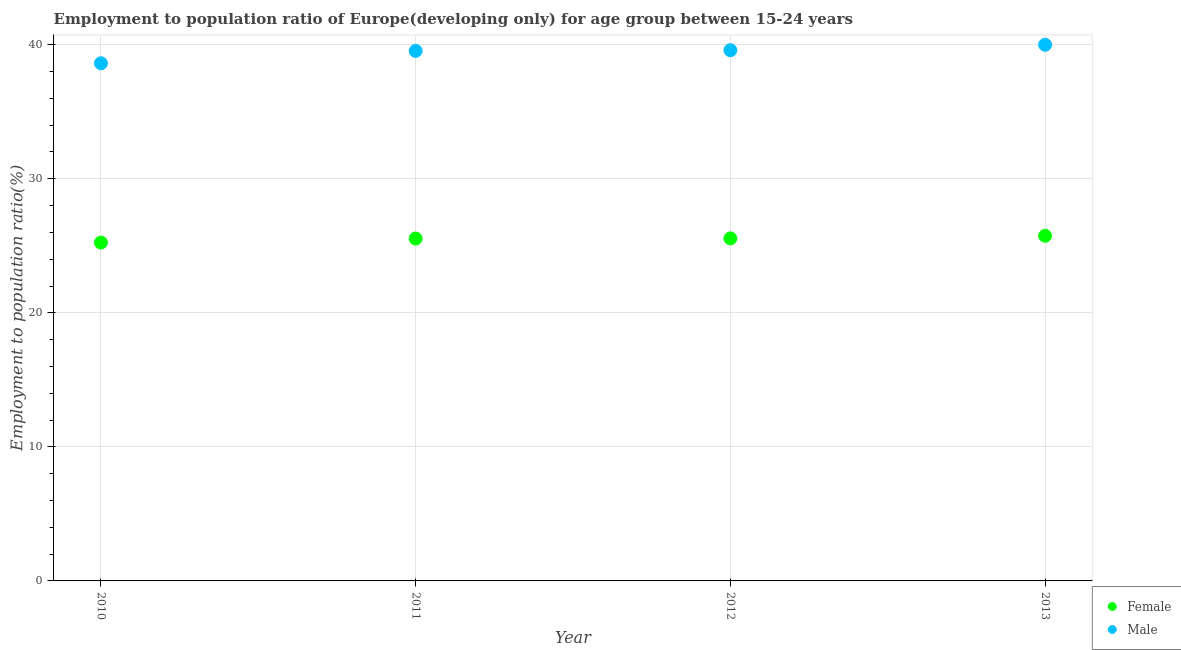How many different coloured dotlines are there?
Your answer should be compact. 2. What is the employment to population ratio(female) in 2012?
Provide a short and direct response. 25.56. Across all years, what is the maximum employment to population ratio(male)?
Offer a very short reply. 40. Across all years, what is the minimum employment to population ratio(male)?
Provide a succinct answer. 38.62. In which year was the employment to population ratio(male) maximum?
Provide a succinct answer. 2013. In which year was the employment to population ratio(male) minimum?
Keep it short and to the point. 2010. What is the total employment to population ratio(male) in the graph?
Your answer should be very brief. 157.75. What is the difference between the employment to population ratio(female) in 2012 and that in 2013?
Your answer should be very brief. -0.19. What is the difference between the employment to population ratio(male) in 2011 and the employment to population ratio(female) in 2010?
Your response must be concise. 14.3. What is the average employment to population ratio(male) per year?
Make the answer very short. 39.44. In the year 2011, what is the difference between the employment to population ratio(female) and employment to population ratio(male)?
Offer a terse response. -14. What is the ratio of the employment to population ratio(female) in 2010 to that in 2013?
Provide a succinct answer. 0.98. Is the employment to population ratio(male) in 2010 less than that in 2012?
Ensure brevity in your answer.  Yes. What is the difference between the highest and the second highest employment to population ratio(female)?
Provide a succinct answer. 0.19. What is the difference between the highest and the lowest employment to population ratio(male)?
Your answer should be very brief. 1.38. In how many years, is the employment to population ratio(male) greater than the average employment to population ratio(male) taken over all years?
Provide a short and direct response. 3. Is the sum of the employment to population ratio(male) in 2011 and 2013 greater than the maximum employment to population ratio(female) across all years?
Your response must be concise. Yes. Does the employment to population ratio(male) monotonically increase over the years?
Your answer should be compact. Yes. Is the employment to population ratio(male) strictly greater than the employment to population ratio(female) over the years?
Your answer should be compact. Yes. How many years are there in the graph?
Keep it short and to the point. 4. Does the graph contain grids?
Offer a very short reply. Yes. Where does the legend appear in the graph?
Keep it short and to the point. Bottom right. How many legend labels are there?
Provide a short and direct response. 2. What is the title of the graph?
Make the answer very short. Employment to population ratio of Europe(developing only) for age group between 15-24 years. What is the Employment to population ratio(%) in Female in 2010?
Provide a short and direct response. 25.24. What is the Employment to population ratio(%) in Male in 2010?
Offer a terse response. 38.62. What is the Employment to population ratio(%) in Female in 2011?
Your answer should be compact. 25.54. What is the Employment to population ratio(%) in Male in 2011?
Provide a succinct answer. 39.54. What is the Employment to population ratio(%) in Female in 2012?
Your response must be concise. 25.56. What is the Employment to population ratio(%) of Male in 2012?
Offer a very short reply. 39.59. What is the Employment to population ratio(%) in Female in 2013?
Make the answer very short. 25.75. What is the Employment to population ratio(%) of Male in 2013?
Offer a very short reply. 40. Across all years, what is the maximum Employment to population ratio(%) of Female?
Make the answer very short. 25.75. Across all years, what is the maximum Employment to population ratio(%) in Male?
Your answer should be compact. 40. Across all years, what is the minimum Employment to population ratio(%) of Female?
Your answer should be very brief. 25.24. Across all years, what is the minimum Employment to population ratio(%) in Male?
Your answer should be very brief. 38.62. What is the total Employment to population ratio(%) in Female in the graph?
Give a very brief answer. 102.09. What is the total Employment to population ratio(%) in Male in the graph?
Give a very brief answer. 157.75. What is the difference between the Employment to population ratio(%) in Female in 2010 and that in 2011?
Ensure brevity in your answer.  -0.3. What is the difference between the Employment to population ratio(%) in Male in 2010 and that in 2011?
Your response must be concise. -0.92. What is the difference between the Employment to population ratio(%) of Female in 2010 and that in 2012?
Make the answer very short. -0.31. What is the difference between the Employment to population ratio(%) of Male in 2010 and that in 2012?
Provide a short and direct response. -0.97. What is the difference between the Employment to population ratio(%) in Female in 2010 and that in 2013?
Your answer should be compact. -0.51. What is the difference between the Employment to population ratio(%) in Male in 2010 and that in 2013?
Provide a short and direct response. -1.38. What is the difference between the Employment to population ratio(%) of Female in 2011 and that in 2012?
Ensure brevity in your answer.  -0.01. What is the difference between the Employment to population ratio(%) in Male in 2011 and that in 2012?
Offer a very short reply. -0.05. What is the difference between the Employment to population ratio(%) in Female in 2011 and that in 2013?
Make the answer very short. -0.21. What is the difference between the Employment to population ratio(%) of Male in 2011 and that in 2013?
Keep it short and to the point. -0.46. What is the difference between the Employment to population ratio(%) of Female in 2012 and that in 2013?
Ensure brevity in your answer.  -0.19. What is the difference between the Employment to population ratio(%) in Male in 2012 and that in 2013?
Give a very brief answer. -0.41. What is the difference between the Employment to population ratio(%) in Female in 2010 and the Employment to population ratio(%) in Male in 2011?
Offer a very short reply. -14.3. What is the difference between the Employment to population ratio(%) in Female in 2010 and the Employment to population ratio(%) in Male in 2012?
Provide a succinct answer. -14.35. What is the difference between the Employment to population ratio(%) of Female in 2010 and the Employment to population ratio(%) of Male in 2013?
Your answer should be very brief. -14.76. What is the difference between the Employment to population ratio(%) of Female in 2011 and the Employment to population ratio(%) of Male in 2012?
Offer a terse response. -14.05. What is the difference between the Employment to population ratio(%) of Female in 2011 and the Employment to population ratio(%) of Male in 2013?
Make the answer very short. -14.46. What is the difference between the Employment to population ratio(%) of Female in 2012 and the Employment to population ratio(%) of Male in 2013?
Your answer should be very brief. -14.44. What is the average Employment to population ratio(%) in Female per year?
Your answer should be compact. 25.52. What is the average Employment to population ratio(%) of Male per year?
Your response must be concise. 39.44. In the year 2010, what is the difference between the Employment to population ratio(%) in Female and Employment to population ratio(%) in Male?
Ensure brevity in your answer.  -13.38. In the year 2011, what is the difference between the Employment to population ratio(%) of Female and Employment to population ratio(%) of Male?
Keep it short and to the point. -14. In the year 2012, what is the difference between the Employment to population ratio(%) of Female and Employment to population ratio(%) of Male?
Make the answer very short. -14.04. In the year 2013, what is the difference between the Employment to population ratio(%) of Female and Employment to population ratio(%) of Male?
Provide a succinct answer. -14.25. What is the ratio of the Employment to population ratio(%) in Female in 2010 to that in 2011?
Keep it short and to the point. 0.99. What is the ratio of the Employment to population ratio(%) in Male in 2010 to that in 2011?
Make the answer very short. 0.98. What is the ratio of the Employment to population ratio(%) of Male in 2010 to that in 2012?
Your response must be concise. 0.98. What is the ratio of the Employment to population ratio(%) in Female in 2010 to that in 2013?
Give a very brief answer. 0.98. What is the ratio of the Employment to population ratio(%) of Male in 2010 to that in 2013?
Offer a very short reply. 0.97. What is the ratio of the Employment to population ratio(%) of Male in 2011 to that in 2012?
Provide a short and direct response. 1. What is the ratio of the Employment to population ratio(%) of Female in 2012 to that in 2013?
Your answer should be very brief. 0.99. What is the difference between the highest and the second highest Employment to population ratio(%) of Female?
Your response must be concise. 0.19. What is the difference between the highest and the second highest Employment to population ratio(%) of Male?
Provide a short and direct response. 0.41. What is the difference between the highest and the lowest Employment to population ratio(%) of Female?
Ensure brevity in your answer.  0.51. What is the difference between the highest and the lowest Employment to population ratio(%) in Male?
Give a very brief answer. 1.38. 